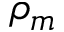Convert formula to latex. <formula><loc_0><loc_0><loc_500><loc_500>\rho _ { m }</formula> 